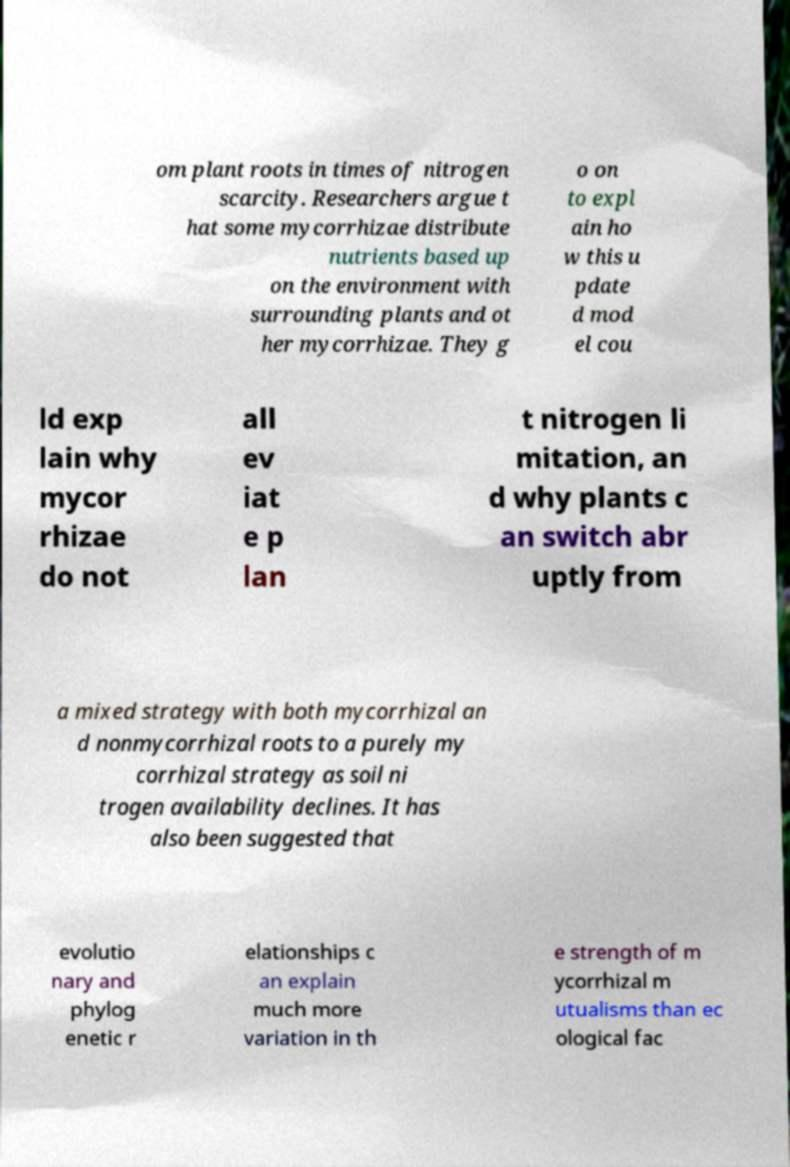For documentation purposes, I need the text within this image transcribed. Could you provide that? om plant roots in times of nitrogen scarcity. Researchers argue t hat some mycorrhizae distribute nutrients based up on the environment with surrounding plants and ot her mycorrhizae. They g o on to expl ain ho w this u pdate d mod el cou ld exp lain why mycor rhizae do not all ev iat e p lan t nitrogen li mitation, an d why plants c an switch abr uptly from a mixed strategy with both mycorrhizal an d nonmycorrhizal roots to a purely my corrhizal strategy as soil ni trogen availability declines. It has also been suggested that evolutio nary and phylog enetic r elationships c an explain much more variation in th e strength of m ycorrhizal m utualisms than ec ological fac 